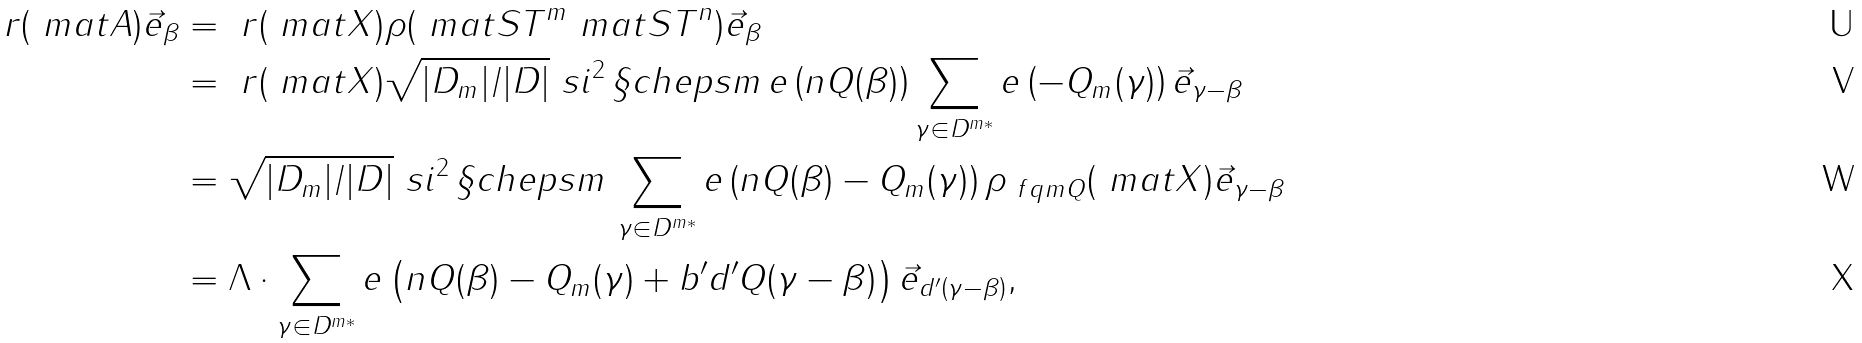<formula> <loc_0><loc_0><loc_500><loc_500>\ r ( \ m a t { A } ) \vec { e } _ { \beta } & = \ r ( \ m a t { X } ) \rho ( \ m a t { S T } ^ { m } \ m a t { S T } ^ { n } ) \vec { e } _ { \beta } \\ & = \ r ( \ m a t { X } ) \sqrt { | D _ { m } | / | D | } \ s i ^ { 2 } \, \S c h e p s { m } \, e \left ( n Q ( \beta ) \right ) \sum _ { \gamma \in D ^ { m * } } e \left ( - Q _ { m } ( \gamma ) \right ) \vec { e } _ { \gamma - \beta } \\ & = \sqrt { | D _ { m } | / | D | } \ s i ^ { 2 } \, \S c h e p s { m } \, \sum _ { \gamma \in D ^ { m * } } e \left ( n Q ( \beta ) - Q _ { m } ( \gamma ) \right ) \rho _ { \ f q m Q } ( \ m a t { X } ) \vec { e } _ { \gamma - \beta } \\ & = \Lambda \cdot \sum _ { \gamma \in D ^ { m * } } e \left ( n Q ( \beta ) - Q _ { m } ( \gamma ) + b ^ { \prime } d ^ { \prime } Q ( \gamma - \beta ) \right ) \vec { e } _ { d ^ { \prime } \left ( \gamma - \beta \right ) } ,</formula> 